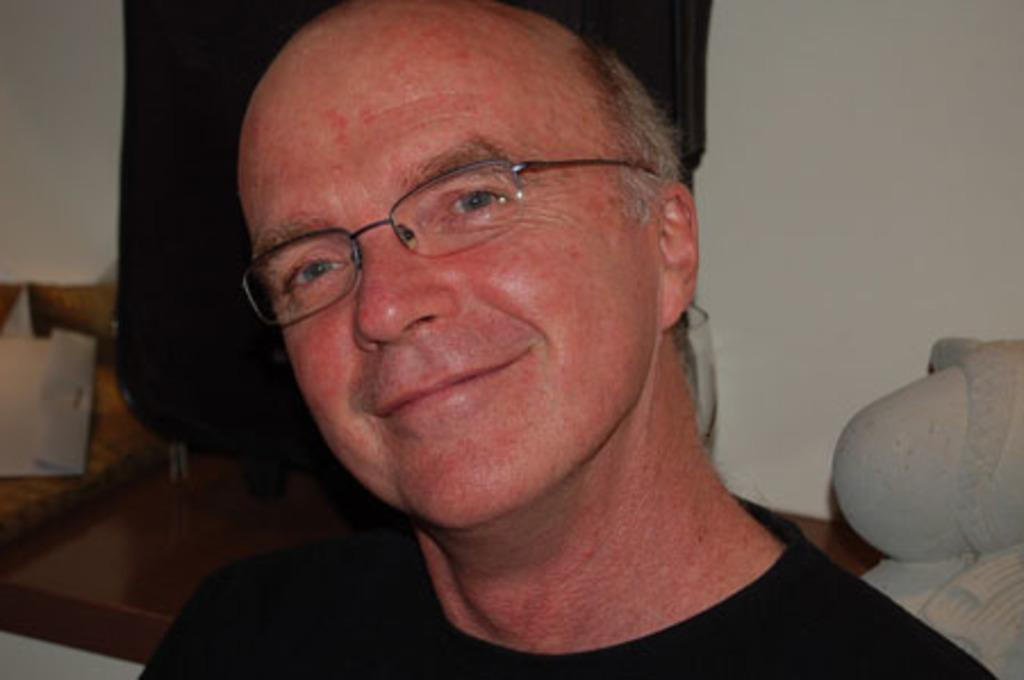Who is present in the image? There is a man in the image. What is the man wearing? The man is wearing spectacles. What can be seen beside the man? There is a bag visible in the image. What is the man holding in the image? There is a glass in the image. What is the man doing with the objects in the image? There are objects placed on a surface in the image, but the man's actions are not specified. What is the background of the image? There is a wall in the image. What type of acoustics can be heard in the image? There is no information about any sounds or acoustics in the image, as it is a still image. Who is the man's friend in the image? There is no information about any friends or relationships in the image, as it only shows a man with some objects. 